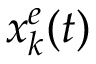<formula> <loc_0><loc_0><loc_500><loc_500>x _ { k } ^ { e } ( t )</formula> 